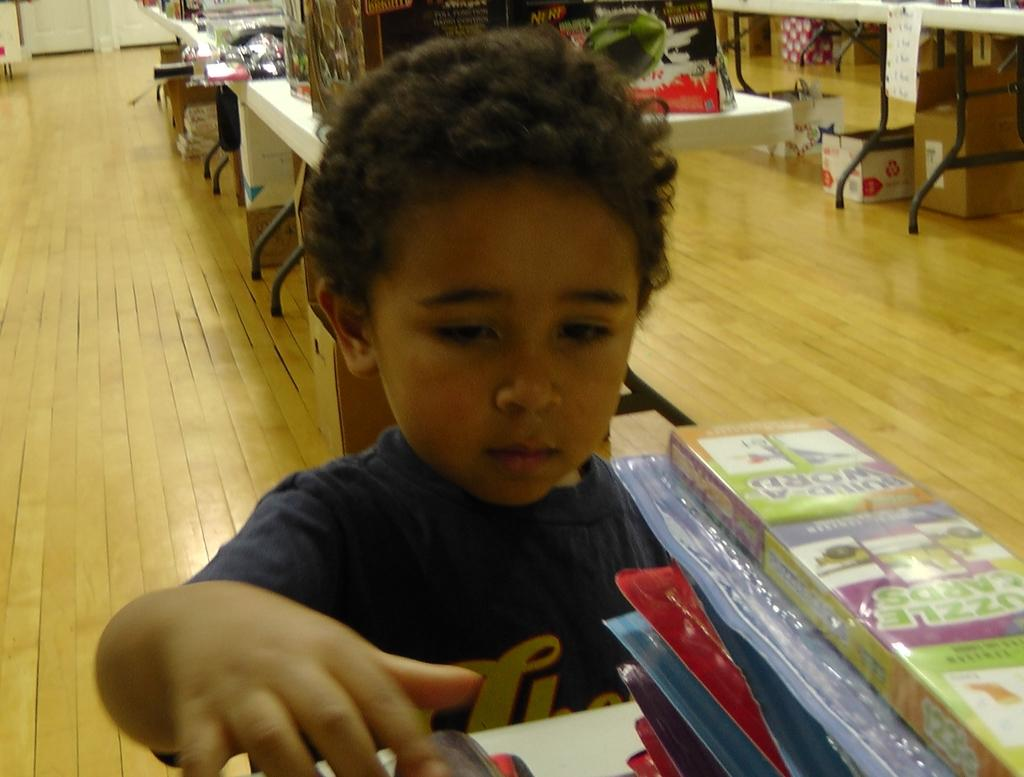What is the main subject in the image? There is a kid standing in the image. What else can be seen in the image besides the kid? There are tables and cartoon boxes on the floor in the image. What type of leather is visible on the tables in the image? There is no leather visible on the tables in the image. The tables are not described in detail, and the presence of leather cannot be determined from the given facts. 